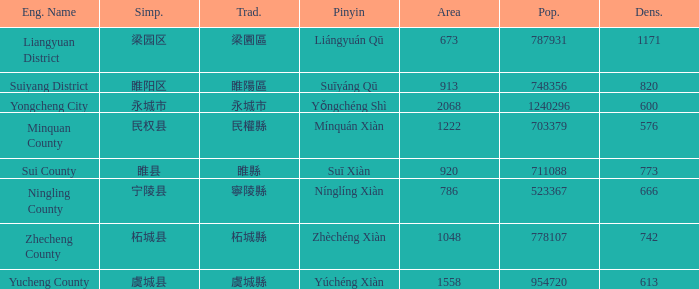What is the Pinyin for the simplified 虞城县? Yúchéng Xiàn. 